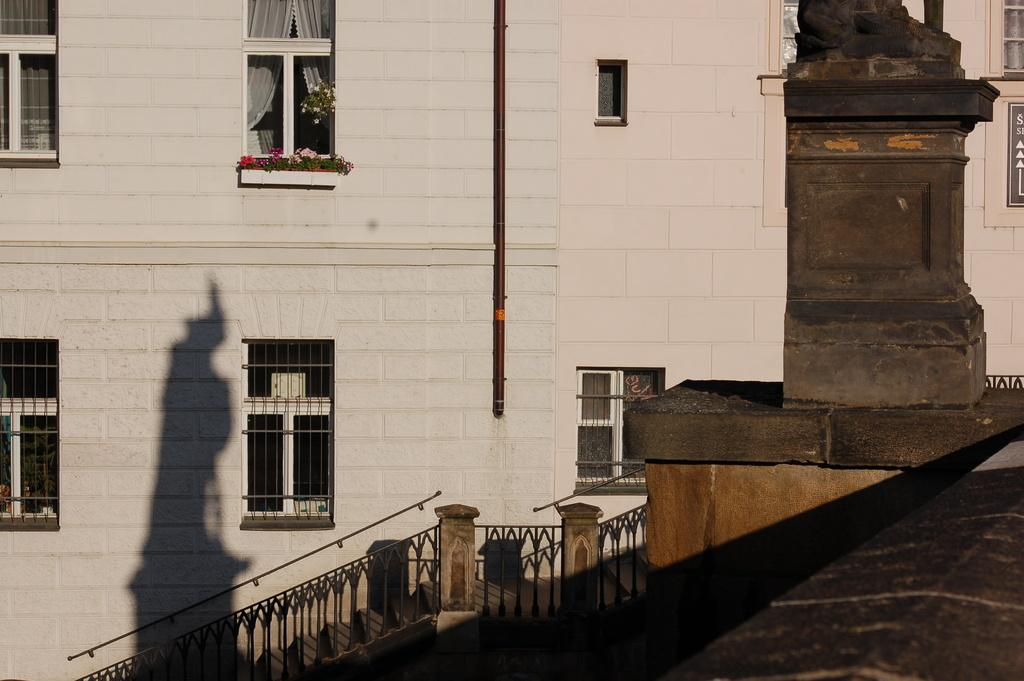What type of structures can be seen in the image? There are buildings in the image. Can you describe any architectural features of the buildings? Yes, there are stairs visible in the image. What can be seen on the walls of the buildings? There are windows on the walls of the buildings. What is the size of the basin located in the image? There is no basin present in the image. What territory does the image represent? The image does not represent any specific territory; it simply shows buildings, stairs, and windows. 